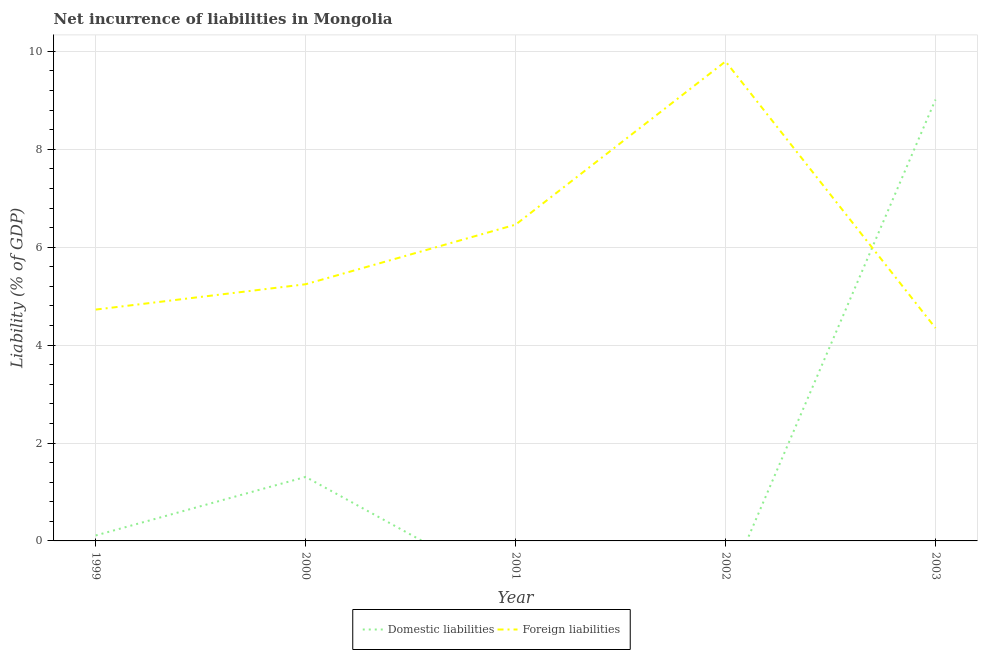How many different coloured lines are there?
Give a very brief answer. 2. Does the line corresponding to incurrence of domestic liabilities intersect with the line corresponding to incurrence of foreign liabilities?
Make the answer very short. Yes. What is the incurrence of foreign liabilities in 2000?
Give a very brief answer. 5.24. Across all years, what is the maximum incurrence of domestic liabilities?
Give a very brief answer. 9.02. Across all years, what is the minimum incurrence of foreign liabilities?
Ensure brevity in your answer.  4.35. In which year was the incurrence of foreign liabilities maximum?
Keep it short and to the point. 2002. What is the total incurrence of foreign liabilities in the graph?
Keep it short and to the point. 30.57. What is the difference between the incurrence of domestic liabilities in 2000 and that in 2003?
Ensure brevity in your answer.  -7.71. What is the difference between the incurrence of domestic liabilities in 1999 and the incurrence of foreign liabilities in 2000?
Your answer should be very brief. -5.13. What is the average incurrence of foreign liabilities per year?
Your answer should be very brief. 6.11. In the year 1999, what is the difference between the incurrence of foreign liabilities and incurrence of domestic liabilities?
Offer a very short reply. 4.61. What is the ratio of the incurrence of foreign liabilities in 2002 to that in 2003?
Make the answer very short. 2.25. What is the difference between the highest and the second highest incurrence of foreign liabilities?
Provide a short and direct response. 3.33. What is the difference between the highest and the lowest incurrence of foreign liabilities?
Your response must be concise. 5.45. Is the sum of the incurrence of foreign liabilities in 2002 and 2003 greater than the maximum incurrence of domestic liabilities across all years?
Provide a short and direct response. Yes. Does the incurrence of foreign liabilities monotonically increase over the years?
Make the answer very short. No. Is the incurrence of domestic liabilities strictly less than the incurrence of foreign liabilities over the years?
Your answer should be very brief. No. Are the values on the major ticks of Y-axis written in scientific E-notation?
Provide a short and direct response. No. How many legend labels are there?
Give a very brief answer. 2. How are the legend labels stacked?
Keep it short and to the point. Horizontal. What is the title of the graph?
Your response must be concise. Net incurrence of liabilities in Mongolia. Does "Food and tobacco" appear as one of the legend labels in the graph?
Your answer should be very brief. No. What is the label or title of the X-axis?
Give a very brief answer. Year. What is the label or title of the Y-axis?
Your answer should be compact. Liability (% of GDP). What is the Liability (% of GDP) in Domestic liabilities in 1999?
Provide a short and direct response. 0.11. What is the Liability (% of GDP) in Foreign liabilities in 1999?
Offer a terse response. 4.73. What is the Liability (% of GDP) in Domestic liabilities in 2000?
Provide a succinct answer. 1.31. What is the Liability (% of GDP) of Foreign liabilities in 2000?
Give a very brief answer. 5.24. What is the Liability (% of GDP) of Domestic liabilities in 2001?
Make the answer very short. 0. What is the Liability (% of GDP) of Foreign liabilities in 2001?
Offer a terse response. 6.46. What is the Liability (% of GDP) of Foreign liabilities in 2002?
Your response must be concise. 9.79. What is the Liability (% of GDP) in Domestic liabilities in 2003?
Offer a terse response. 9.02. What is the Liability (% of GDP) of Foreign liabilities in 2003?
Your answer should be compact. 4.35. Across all years, what is the maximum Liability (% of GDP) in Domestic liabilities?
Make the answer very short. 9.02. Across all years, what is the maximum Liability (% of GDP) in Foreign liabilities?
Offer a terse response. 9.79. Across all years, what is the minimum Liability (% of GDP) in Domestic liabilities?
Keep it short and to the point. 0. Across all years, what is the minimum Liability (% of GDP) in Foreign liabilities?
Offer a terse response. 4.35. What is the total Liability (% of GDP) in Domestic liabilities in the graph?
Give a very brief answer. 10.43. What is the total Liability (% of GDP) in Foreign liabilities in the graph?
Give a very brief answer. 30.57. What is the difference between the Liability (% of GDP) in Domestic liabilities in 1999 and that in 2000?
Your response must be concise. -1.2. What is the difference between the Liability (% of GDP) in Foreign liabilities in 1999 and that in 2000?
Give a very brief answer. -0.52. What is the difference between the Liability (% of GDP) of Foreign liabilities in 1999 and that in 2001?
Ensure brevity in your answer.  -1.74. What is the difference between the Liability (% of GDP) of Foreign liabilities in 1999 and that in 2002?
Give a very brief answer. -5.07. What is the difference between the Liability (% of GDP) in Domestic liabilities in 1999 and that in 2003?
Make the answer very short. -8.9. What is the difference between the Liability (% of GDP) in Foreign liabilities in 1999 and that in 2003?
Offer a very short reply. 0.38. What is the difference between the Liability (% of GDP) in Foreign liabilities in 2000 and that in 2001?
Ensure brevity in your answer.  -1.22. What is the difference between the Liability (% of GDP) in Foreign liabilities in 2000 and that in 2002?
Your response must be concise. -4.55. What is the difference between the Liability (% of GDP) of Domestic liabilities in 2000 and that in 2003?
Your response must be concise. -7.71. What is the difference between the Liability (% of GDP) of Foreign liabilities in 2000 and that in 2003?
Your answer should be compact. 0.9. What is the difference between the Liability (% of GDP) in Foreign liabilities in 2001 and that in 2002?
Provide a succinct answer. -3.33. What is the difference between the Liability (% of GDP) of Foreign liabilities in 2001 and that in 2003?
Ensure brevity in your answer.  2.11. What is the difference between the Liability (% of GDP) in Foreign liabilities in 2002 and that in 2003?
Your answer should be compact. 5.45. What is the difference between the Liability (% of GDP) in Domestic liabilities in 1999 and the Liability (% of GDP) in Foreign liabilities in 2000?
Provide a short and direct response. -5.13. What is the difference between the Liability (% of GDP) of Domestic liabilities in 1999 and the Liability (% of GDP) of Foreign liabilities in 2001?
Ensure brevity in your answer.  -6.35. What is the difference between the Liability (% of GDP) in Domestic liabilities in 1999 and the Liability (% of GDP) in Foreign liabilities in 2002?
Keep it short and to the point. -9.68. What is the difference between the Liability (% of GDP) of Domestic liabilities in 1999 and the Liability (% of GDP) of Foreign liabilities in 2003?
Your answer should be compact. -4.24. What is the difference between the Liability (% of GDP) in Domestic liabilities in 2000 and the Liability (% of GDP) in Foreign liabilities in 2001?
Offer a very short reply. -5.15. What is the difference between the Liability (% of GDP) in Domestic liabilities in 2000 and the Liability (% of GDP) in Foreign liabilities in 2002?
Your answer should be very brief. -8.49. What is the difference between the Liability (% of GDP) of Domestic liabilities in 2000 and the Liability (% of GDP) of Foreign liabilities in 2003?
Provide a short and direct response. -3.04. What is the average Liability (% of GDP) in Domestic liabilities per year?
Your answer should be compact. 2.09. What is the average Liability (% of GDP) in Foreign liabilities per year?
Your answer should be compact. 6.11. In the year 1999, what is the difference between the Liability (% of GDP) of Domestic liabilities and Liability (% of GDP) of Foreign liabilities?
Your response must be concise. -4.61. In the year 2000, what is the difference between the Liability (% of GDP) in Domestic liabilities and Liability (% of GDP) in Foreign liabilities?
Offer a terse response. -3.94. In the year 2003, what is the difference between the Liability (% of GDP) of Domestic liabilities and Liability (% of GDP) of Foreign liabilities?
Provide a succinct answer. 4.67. What is the ratio of the Liability (% of GDP) of Domestic liabilities in 1999 to that in 2000?
Make the answer very short. 0.09. What is the ratio of the Liability (% of GDP) of Foreign liabilities in 1999 to that in 2000?
Your answer should be compact. 0.9. What is the ratio of the Liability (% of GDP) of Foreign liabilities in 1999 to that in 2001?
Your answer should be compact. 0.73. What is the ratio of the Liability (% of GDP) of Foreign liabilities in 1999 to that in 2002?
Offer a terse response. 0.48. What is the ratio of the Liability (% of GDP) of Domestic liabilities in 1999 to that in 2003?
Offer a terse response. 0.01. What is the ratio of the Liability (% of GDP) of Foreign liabilities in 1999 to that in 2003?
Offer a very short reply. 1.09. What is the ratio of the Liability (% of GDP) of Foreign liabilities in 2000 to that in 2001?
Make the answer very short. 0.81. What is the ratio of the Liability (% of GDP) in Foreign liabilities in 2000 to that in 2002?
Your answer should be compact. 0.54. What is the ratio of the Liability (% of GDP) of Domestic liabilities in 2000 to that in 2003?
Provide a succinct answer. 0.15. What is the ratio of the Liability (% of GDP) in Foreign liabilities in 2000 to that in 2003?
Your response must be concise. 1.21. What is the ratio of the Liability (% of GDP) of Foreign liabilities in 2001 to that in 2002?
Offer a very short reply. 0.66. What is the ratio of the Liability (% of GDP) of Foreign liabilities in 2001 to that in 2003?
Ensure brevity in your answer.  1.49. What is the ratio of the Liability (% of GDP) of Foreign liabilities in 2002 to that in 2003?
Give a very brief answer. 2.25. What is the difference between the highest and the second highest Liability (% of GDP) in Domestic liabilities?
Keep it short and to the point. 7.71. What is the difference between the highest and the second highest Liability (% of GDP) of Foreign liabilities?
Provide a succinct answer. 3.33. What is the difference between the highest and the lowest Liability (% of GDP) in Domestic liabilities?
Ensure brevity in your answer.  9.02. What is the difference between the highest and the lowest Liability (% of GDP) of Foreign liabilities?
Your answer should be compact. 5.45. 